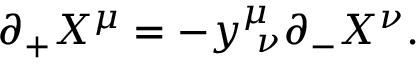<formula> <loc_0><loc_0><loc_500><loc_500>\partial _ { + } X ^ { \mu } = - y _ { \nu } ^ { \mu } \partial _ { - } X ^ { \nu } .</formula> 